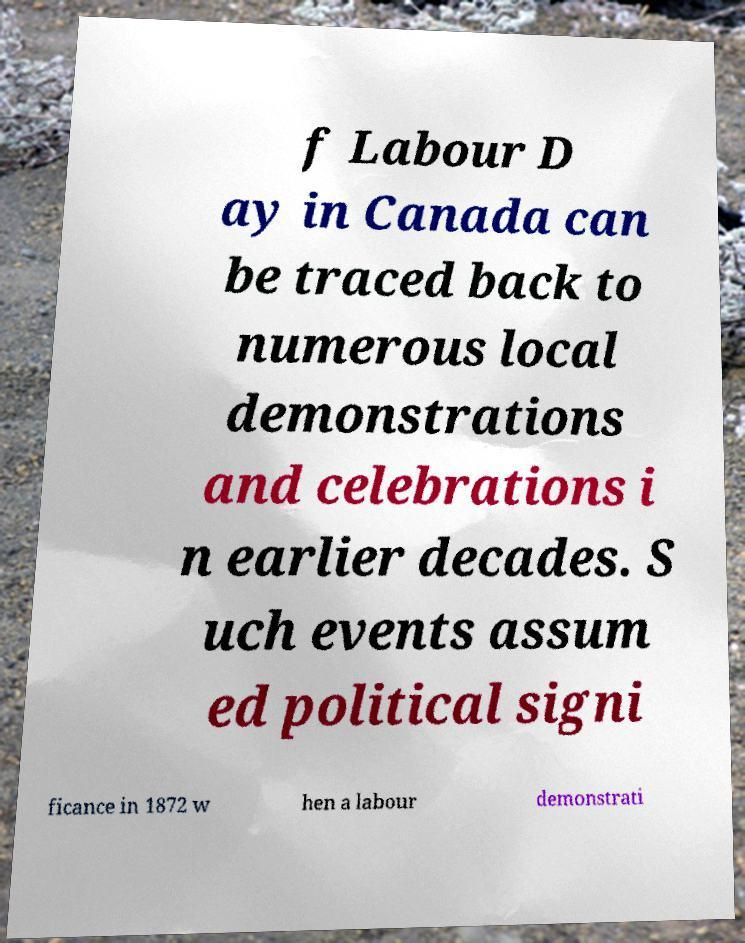Can you accurately transcribe the text from the provided image for me? f Labour D ay in Canada can be traced back to numerous local demonstrations and celebrations i n earlier decades. S uch events assum ed political signi ficance in 1872 w hen a labour demonstrati 